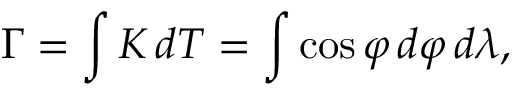Convert formula to latex. <formula><loc_0><loc_0><loc_500><loc_500>\Gamma = \int K \, d T = \int \cos \varphi \, d \varphi \, d \lambda ,</formula> 